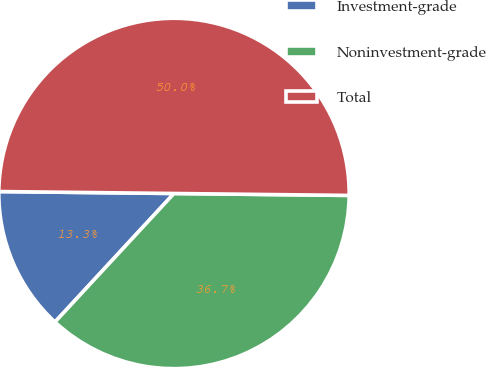Convert chart to OTSL. <chart><loc_0><loc_0><loc_500><loc_500><pie_chart><fcel>Investment-grade<fcel>Noninvestment-grade<fcel>Total<nl><fcel>13.29%<fcel>36.71%<fcel>50.0%<nl></chart> 